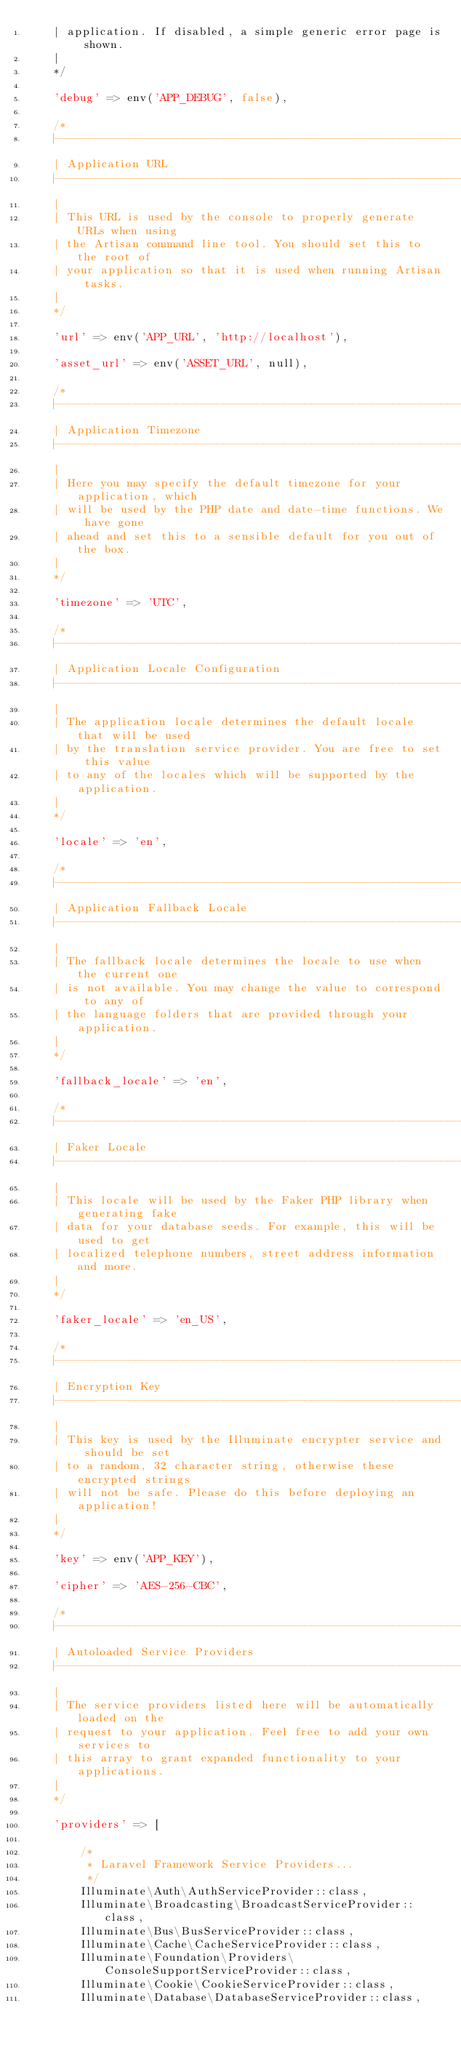Convert code to text. <code><loc_0><loc_0><loc_500><loc_500><_PHP_>    | application. If disabled, a simple generic error page is shown.
    |
    */

    'debug' => env('APP_DEBUG', false),

    /*
    |--------------------------------------------------------------------------
    | Application URL
    |--------------------------------------------------------------------------
    |
    | This URL is used by the console to properly generate URLs when using
    | the Artisan command line tool. You should set this to the root of
    | your application so that it is used when running Artisan tasks.
    |
    */

    'url' => env('APP_URL', 'http://localhost'),

    'asset_url' => env('ASSET_URL', null),

    /*
    |--------------------------------------------------------------------------
    | Application Timezone
    |--------------------------------------------------------------------------
    |
    | Here you may specify the default timezone for your application, which
    | will be used by the PHP date and date-time functions. We have gone
    | ahead and set this to a sensible default for you out of the box.
    |
    */

    'timezone' => 'UTC',

    /*
    |--------------------------------------------------------------------------
    | Application Locale Configuration
    |--------------------------------------------------------------------------
    |
    | The application locale determines the default locale that will be used
    | by the translation service provider. You are free to set this value
    | to any of the locales which will be supported by the application.
    |
    */

    'locale' => 'en',

    /*
    |--------------------------------------------------------------------------
    | Application Fallback Locale
    |--------------------------------------------------------------------------
    |
    | The fallback locale determines the locale to use when the current one
    | is not available. You may change the value to correspond to any of
    | the language folders that are provided through your application.
    |
    */

    'fallback_locale' => 'en',

    /*
    |--------------------------------------------------------------------------
    | Faker Locale
    |--------------------------------------------------------------------------
    |
    | This locale will be used by the Faker PHP library when generating fake
    | data for your database seeds. For example, this will be used to get
    | localized telephone numbers, street address information and more.
    |
    */

    'faker_locale' => 'en_US',

    /*
    |--------------------------------------------------------------------------
    | Encryption Key
    |--------------------------------------------------------------------------
    |
    | This key is used by the Illuminate encrypter service and should be set
    | to a random, 32 character string, otherwise these encrypted strings
    | will not be safe. Please do this before deploying an application!
    |
    */

    'key' => env('APP_KEY'),

    'cipher' => 'AES-256-CBC',

    /*
    |--------------------------------------------------------------------------
    | Autoloaded Service Providers
    |--------------------------------------------------------------------------
    |
    | The service providers listed here will be automatically loaded on the
    | request to your application. Feel free to add your own services to
    | this array to grant expanded functionality to your applications.
    |
    */

    'providers' => [

        /*
         * Laravel Framework Service Providers...
         */
        Illuminate\Auth\AuthServiceProvider::class,
        Illuminate\Broadcasting\BroadcastServiceProvider::class,
        Illuminate\Bus\BusServiceProvider::class,
        Illuminate\Cache\CacheServiceProvider::class,
        Illuminate\Foundation\Providers\ConsoleSupportServiceProvider::class,
        Illuminate\Cookie\CookieServiceProvider::class,
        Illuminate\Database\DatabaseServiceProvider::class,</code> 